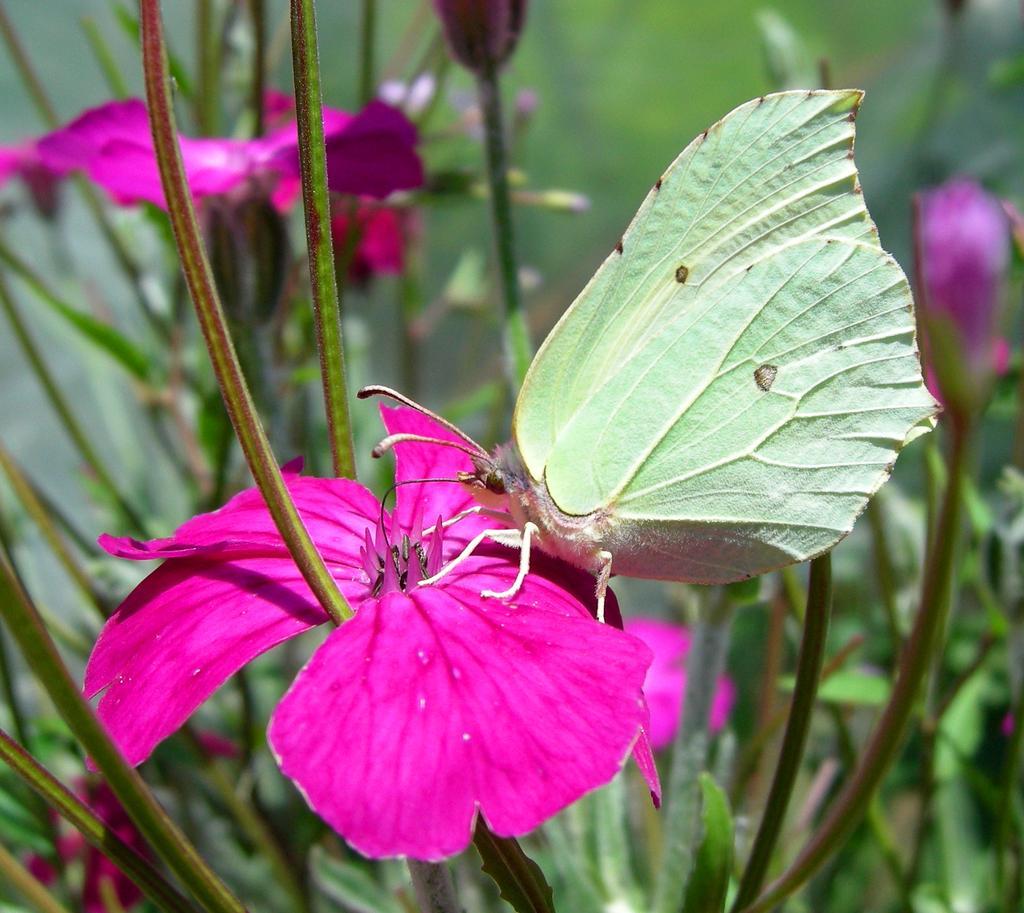Please provide a concise description of this image. In this image we can see plants with flowers. On the flower there is a butterfly. In the background it is blur. 